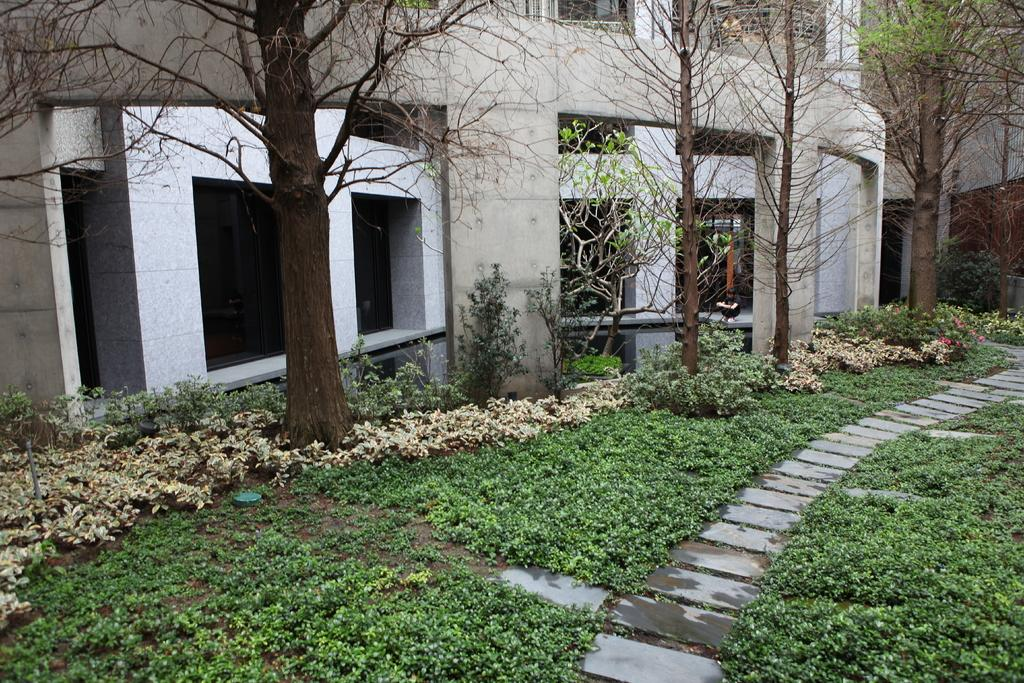What is the main structure in the center of the image? There is a building in the center of the image. What architectural features can be seen in the image? There are pillars in the image. What type of vegetation is present in the image? There are trees, plants, and grass in the image. What type of ground surface is visible in the image? There are stones in the image. Are there any other objects or features in the image? Yes, there are a few other objects in the image. How many tubes of glue are visible in the image? There are no tubes of glue present in the image. What type of umbrella is being used by the person in the image? There is no person or umbrella present in the image. 